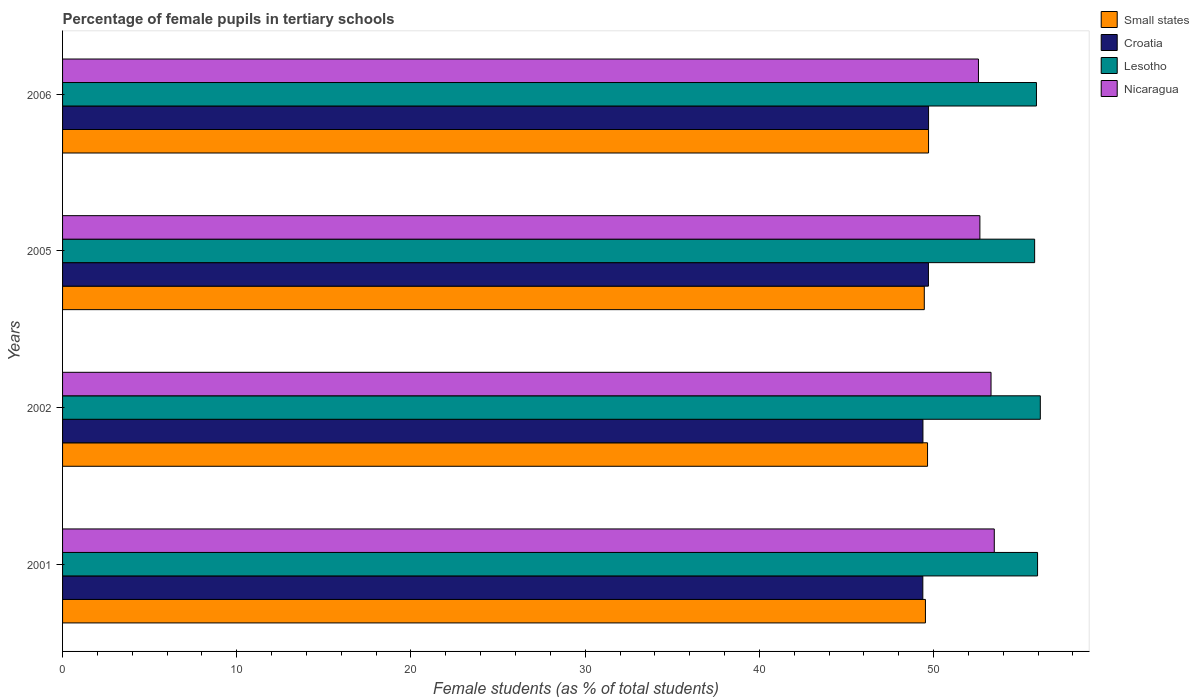Are the number of bars per tick equal to the number of legend labels?
Keep it short and to the point. Yes. Are the number of bars on each tick of the Y-axis equal?
Your answer should be compact. Yes. How many bars are there on the 2nd tick from the bottom?
Give a very brief answer. 4. In how many cases, is the number of bars for a given year not equal to the number of legend labels?
Offer a very short reply. 0. What is the percentage of female pupils in tertiary schools in Nicaragua in 2005?
Your answer should be compact. 52.66. Across all years, what is the maximum percentage of female pupils in tertiary schools in Lesotho?
Ensure brevity in your answer.  56.13. Across all years, what is the minimum percentage of female pupils in tertiary schools in Croatia?
Make the answer very short. 49.38. In which year was the percentage of female pupils in tertiary schools in Nicaragua maximum?
Provide a short and direct response. 2001. What is the total percentage of female pupils in tertiary schools in Croatia in the graph?
Your response must be concise. 198.19. What is the difference between the percentage of female pupils in tertiary schools in Nicaragua in 2001 and that in 2002?
Ensure brevity in your answer.  0.19. What is the difference between the percentage of female pupils in tertiary schools in Nicaragua in 2005 and the percentage of female pupils in tertiary schools in Small states in 2002?
Provide a short and direct response. 3. What is the average percentage of female pupils in tertiary schools in Nicaragua per year?
Provide a succinct answer. 53.01. In the year 2006, what is the difference between the percentage of female pupils in tertiary schools in Small states and percentage of female pupils in tertiary schools in Croatia?
Make the answer very short. -0. In how many years, is the percentage of female pupils in tertiary schools in Croatia greater than 22 %?
Your response must be concise. 4. What is the ratio of the percentage of female pupils in tertiary schools in Nicaragua in 2002 to that in 2005?
Your response must be concise. 1.01. What is the difference between the highest and the second highest percentage of female pupils in tertiary schools in Small states?
Make the answer very short. 0.06. What is the difference between the highest and the lowest percentage of female pupils in tertiary schools in Small states?
Ensure brevity in your answer.  0.24. In how many years, is the percentage of female pupils in tertiary schools in Croatia greater than the average percentage of female pupils in tertiary schools in Croatia taken over all years?
Your answer should be compact. 2. Is the sum of the percentage of female pupils in tertiary schools in Lesotho in 2001 and 2006 greater than the maximum percentage of female pupils in tertiary schools in Croatia across all years?
Your answer should be very brief. Yes. What does the 3rd bar from the top in 2005 represents?
Your response must be concise. Croatia. What does the 3rd bar from the bottom in 2005 represents?
Provide a succinct answer. Lesotho. Is it the case that in every year, the sum of the percentage of female pupils in tertiary schools in Croatia and percentage of female pupils in tertiary schools in Lesotho is greater than the percentage of female pupils in tertiary schools in Nicaragua?
Provide a short and direct response. Yes. How many bars are there?
Make the answer very short. 16. Are all the bars in the graph horizontal?
Offer a terse response. Yes. What is the difference between two consecutive major ticks on the X-axis?
Offer a terse response. 10. Does the graph contain any zero values?
Make the answer very short. No. Where does the legend appear in the graph?
Provide a succinct answer. Top right. What is the title of the graph?
Your answer should be compact. Percentage of female pupils in tertiary schools. Does "Sub-Saharan Africa (all income levels)" appear as one of the legend labels in the graph?
Make the answer very short. No. What is the label or title of the X-axis?
Keep it short and to the point. Female students (as % of total students). What is the Female students (as % of total students) of Small states in 2001?
Offer a terse response. 49.53. What is the Female students (as % of total students) of Croatia in 2001?
Your answer should be compact. 49.38. What is the Female students (as % of total students) of Lesotho in 2001?
Your answer should be very brief. 55.97. What is the Female students (as % of total students) in Nicaragua in 2001?
Ensure brevity in your answer.  53.49. What is the Female students (as % of total students) of Small states in 2002?
Keep it short and to the point. 49.66. What is the Female students (as % of total students) in Croatia in 2002?
Your answer should be compact. 49.39. What is the Female students (as % of total students) in Lesotho in 2002?
Your answer should be compact. 56.13. What is the Female students (as % of total students) in Nicaragua in 2002?
Offer a terse response. 53.3. What is the Female students (as % of total students) of Small states in 2005?
Provide a short and direct response. 49.47. What is the Female students (as % of total students) of Croatia in 2005?
Provide a succinct answer. 49.71. What is the Female students (as % of total students) of Lesotho in 2005?
Your answer should be very brief. 55.8. What is the Female students (as % of total students) of Nicaragua in 2005?
Your response must be concise. 52.66. What is the Female students (as % of total students) in Small states in 2006?
Your response must be concise. 49.71. What is the Female students (as % of total students) of Croatia in 2006?
Make the answer very short. 49.71. What is the Female students (as % of total students) in Lesotho in 2006?
Make the answer very short. 55.91. What is the Female students (as % of total students) of Nicaragua in 2006?
Provide a succinct answer. 52.58. Across all years, what is the maximum Female students (as % of total students) of Small states?
Make the answer very short. 49.71. Across all years, what is the maximum Female students (as % of total students) of Croatia?
Offer a terse response. 49.71. Across all years, what is the maximum Female students (as % of total students) in Lesotho?
Keep it short and to the point. 56.13. Across all years, what is the maximum Female students (as % of total students) in Nicaragua?
Your answer should be very brief. 53.49. Across all years, what is the minimum Female students (as % of total students) of Small states?
Ensure brevity in your answer.  49.47. Across all years, what is the minimum Female students (as % of total students) of Croatia?
Offer a very short reply. 49.38. Across all years, what is the minimum Female students (as % of total students) of Lesotho?
Make the answer very short. 55.8. Across all years, what is the minimum Female students (as % of total students) in Nicaragua?
Provide a short and direct response. 52.58. What is the total Female students (as % of total students) in Small states in the graph?
Your response must be concise. 198.37. What is the total Female students (as % of total students) of Croatia in the graph?
Provide a short and direct response. 198.19. What is the total Female students (as % of total students) in Lesotho in the graph?
Give a very brief answer. 223.81. What is the total Female students (as % of total students) of Nicaragua in the graph?
Keep it short and to the point. 212.02. What is the difference between the Female students (as % of total students) in Small states in 2001 and that in 2002?
Offer a terse response. -0.12. What is the difference between the Female students (as % of total students) in Croatia in 2001 and that in 2002?
Provide a succinct answer. -0.01. What is the difference between the Female students (as % of total students) in Lesotho in 2001 and that in 2002?
Your response must be concise. -0.16. What is the difference between the Female students (as % of total students) in Nicaragua in 2001 and that in 2002?
Keep it short and to the point. 0.19. What is the difference between the Female students (as % of total students) in Small states in 2001 and that in 2005?
Make the answer very short. 0.07. What is the difference between the Female students (as % of total students) of Croatia in 2001 and that in 2005?
Ensure brevity in your answer.  -0.32. What is the difference between the Female students (as % of total students) in Lesotho in 2001 and that in 2005?
Your answer should be very brief. 0.17. What is the difference between the Female students (as % of total students) of Nicaragua in 2001 and that in 2005?
Your response must be concise. 0.83. What is the difference between the Female students (as % of total students) in Small states in 2001 and that in 2006?
Provide a succinct answer. -0.18. What is the difference between the Female students (as % of total students) of Croatia in 2001 and that in 2006?
Your response must be concise. -0.33. What is the difference between the Female students (as % of total students) of Lesotho in 2001 and that in 2006?
Keep it short and to the point. 0.06. What is the difference between the Female students (as % of total students) in Small states in 2002 and that in 2005?
Give a very brief answer. 0.19. What is the difference between the Female students (as % of total students) of Croatia in 2002 and that in 2005?
Your answer should be very brief. -0.32. What is the difference between the Female students (as % of total students) of Lesotho in 2002 and that in 2005?
Make the answer very short. 0.33. What is the difference between the Female students (as % of total students) of Nicaragua in 2002 and that in 2005?
Provide a succinct answer. 0.64. What is the difference between the Female students (as % of total students) in Small states in 2002 and that in 2006?
Provide a short and direct response. -0.06. What is the difference between the Female students (as % of total students) in Croatia in 2002 and that in 2006?
Your answer should be very brief. -0.32. What is the difference between the Female students (as % of total students) in Lesotho in 2002 and that in 2006?
Your answer should be very brief. 0.22. What is the difference between the Female students (as % of total students) of Nicaragua in 2002 and that in 2006?
Your response must be concise. 0.72. What is the difference between the Female students (as % of total students) of Small states in 2005 and that in 2006?
Offer a very short reply. -0.24. What is the difference between the Female students (as % of total students) in Croatia in 2005 and that in 2006?
Keep it short and to the point. -0.01. What is the difference between the Female students (as % of total students) of Lesotho in 2005 and that in 2006?
Offer a terse response. -0.1. What is the difference between the Female students (as % of total students) of Nicaragua in 2005 and that in 2006?
Provide a short and direct response. 0.08. What is the difference between the Female students (as % of total students) of Small states in 2001 and the Female students (as % of total students) of Croatia in 2002?
Give a very brief answer. 0.14. What is the difference between the Female students (as % of total students) in Small states in 2001 and the Female students (as % of total students) in Lesotho in 2002?
Provide a succinct answer. -6.59. What is the difference between the Female students (as % of total students) in Small states in 2001 and the Female students (as % of total students) in Nicaragua in 2002?
Provide a short and direct response. -3.77. What is the difference between the Female students (as % of total students) in Croatia in 2001 and the Female students (as % of total students) in Lesotho in 2002?
Make the answer very short. -6.74. What is the difference between the Female students (as % of total students) of Croatia in 2001 and the Female students (as % of total students) of Nicaragua in 2002?
Make the answer very short. -3.92. What is the difference between the Female students (as % of total students) in Lesotho in 2001 and the Female students (as % of total students) in Nicaragua in 2002?
Your answer should be very brief. 2.67. What is the difference between the Female students (as % of total students) in Small states in 2001 and the Female students (as % of total students) in Croatia in 2005?
Make the answer very short. -0.17. What is the difference between the Female students (as % of total students) in Small states in 2001 and the Female students (as % of total students) in Lesotho in 2005?
Your answer should be very brief. -6.27. What is the difference between the Female students (as % of total students) in Small states in 2001 and the Female students (as % of total students) in Nicaragua in 2005?
Keep it short and to the point. -3.13. What is the difference between the Female students (as % of total students) of Croatia in 2001 and the Female students (as % of total students) of Lesotho in 2005?
Your answer should be compact. -6.42. What is the difference between the Female students (as % of total students) in Croatia in 2001 and the Female students (as % of total students) in Nicaragua in 2005?
Keep it short and to the point. -3.28. What is the difference between the Female students (as % of total students) of Lesotho in 2001 and the Female students (as % of total students) of Nicaragua in 2005?
Provide a succinct answer. 3.31. What is the difference between the Female students (as % of total students) in Small states in 2001 and the Female students (as % of total students) in Croatia in 2006?
Keep it short and to the point. -0.18. What is the difference between the Female students (as % of total students) in Small states in 2001 and the Female students (as % of total students) in Lesotho in 2006?
Your answer should be very brief. -6.37. What is the difference between the Female students (as % of total students) of Small states in 2001 and the Female students (as % of total students) of Nicaragua in 2006?
Ensure brevity in your answer.  -3.04. What is the difference between the Female students (as % of total students) in Croatia in 2001 and the Female students (as % of total students) in Lesotho in 2006?
Your answer should be compact. -6.52. What is the difference between the Female students (as % of total students) in Croatia in 2001 and the Female students (as % of total students) in Nicaragua in 2006?
Provide a short and direct response. -3.19. What is the difference between the Female students (as % of total students) of Lesotho in 2001 and the Female students (as % of total students) of Nicaragua in 2006?
Your response must be concise. 3.39. What is the difference between the Female students (as % of total students) of Small states in 2002 and the Female students (as % of total students) of Croatia in 2005?
Make the answer very short. -0.05. What is the difference between the Female students (as % of total students) in Small states in 2002 and the Female students (as % of total students) in Lesotho in 2005?
Give a very brief answer. -6.15. What is the difference between the Female students (as % of total students) in Small states in 2002 and the Female students (as % of total students) in Nicaragua in 2005?
Make the answer very short. -3. What is the difference between the Female students (as % of total students) in Croatia in 2002 and the Female students (as % of total students) in Lesotho in 2005?
Offer a very short reply. -6.41. What is the difference between the Female students (as % of total students) of Croatia in 2002 and the Female students (as % of total students) of Nicaragua in 2005?
Your answer should be very brief. -3.27. What is the difference between the Female students (as % of total students) of Lesotho in 2002 and the Female students (as % of total students) of Nicaragua in 2005?
Your response must be concise. 3.47. What is the difference between the Female students (as % of total students) of Small states in 2002 and the Female students (as % of total students) of Croatia in 2006?
Your answer should be very brief. -0.06. What is the difference between the Female students (as % of total students) in Small states in 2002 and the Female students (as % of total students) in Lesotho in 2006?
Offer a very short reply. -6.25. What is the difference between the Female students (as % of total students) in Small states in 2002 and the Female students (as % of total students) in Nicaragua in 2006?
Give a very brief answer. -2.92. What is the difference between the Female students (as % of total students) in Croatia in 2002 and the Female students (as % of total students) in Lesotho in 2006?
Keep it short and to the point. -6.52. What is the difference between the Female students (as % of total students) in Croatia in 2002 and the Female students (as % of total students) in Nicaragua in 2006?
Your answer should be very brief. -3.19. What is the difference between the Female students (as % of total students) in Lesotho in 2002 and the Female students (as % of total students) in Nicaragua in 2006?
Offer a very short reply. 3.55. What is the difference between the Female students (as % of total students) of Small states in 2005 and the Female students (as % of total students) of Croatia in 2006?
Keep it short and to the point. -0.24. What is the difference between the Female students (as % of total students) of Small states in 2005 and the Female students (as % of total students) of Lesotho in 2006?
Your response must be concise. -6.44. What is the difference between the Female students (as % of total students) in Small states in 2005 and the Female students (as % of total students) in Nicaragua in 2006?
Your answer should be very brief. -3.11. What is the difference between the Female students (as % of total students) of Croatia in 2005 and the Female students (as % of total students) of Lesotho in 2006?
Your answer should be compact. -6.2. What is the difference between the Female students (as % of total students) of Croatia in 2005 and the Female students (as % of total students) of Nicaragua in 2006?
Ensure brevity in your answer.  -2.87. What is the difference between the Female students (as % of total students) of Lesotho in 2005 and the Female students (as % of total students) of Nicaragua in 2006?
Offer a very short reply. 3.23. What is the average Female students (as % of total students) of Small states per year?
Make the answer very short. 49.59. What is the average Female students (as % of total students) in Croatia per year?
Make the answer very short. 49.55. What is the average Female students (as % of total students) of Lesotho per year?
Provide a short and direct response. 55.95. What is the average Female students (as % of total students) of Nicaragua per year?
Provide a succinct answer. 53.01. In the year 2001, what is the difference between the Female students (as % of total students) in Small states and Female students (as % of total students) in Croatia?
Give a very brief answer. 0.15. In the year 2001, what is the difference between the Female students (as % of total students) in Small states and Female students (as % of total students) in Lesotho?
Offer a very short reply. -6.44. In the year 2001, what is the difference between the Female students (as % of total students) in Small states and Female students (as % of total students) in Nicaragua?
Ensure brevity in your answer.  -3.95. In the year 2001, what is the difference between the Female students (as % of total students) in Croatia and Female students (as % of total students) in Lesotho?
Offer a terse response. -6.59. In the year 2001, what is the difference between the Female students (as % of total students) in Croatia and Female students (as % of total students) in Nicaragua?
Make the answer very short. -4.1. In the year 2001, what is the difference between the Female students (as % of total students) in Lesotho and Female students (as % of total students) in Nicaragua?
Keep it short and to the point. 2.48. In the year 2002, what is the difference between the Female students (as % of total students) of Small states and Female students (as % of total students) of Croatia?
Offer a terse response. 0.27. In the year 2002, what is the difference between the Female students (as % of total students) in Small states and Female students (as % of total students) in Lesotho?
Offer a terse response. -6.47. In the year 2002, what is the difference between the Female students (as % of total students) of Small states and Female students (as % of total students) of Nicaragua?
Provide a succinct answer. -3.64. In the year 2002, what is the difference between the Female students (as % of total students) of Croatia and Female students (as % of total students) of Lesotho?
Keep it short and to the point. -6.74. In the year 2002, what is the difference between the Female students (as % of total students) in Croatia and Female students (as % of total students) in Nicaragua?
Your answer should be compact. -3.91. In the year 2002, what is the difference between the Female students (as % of total students) of Lesotho and Female students (as % of total students) of Nicaragua?
Give a very brief answer. 2.83. In the year 2005, what is the difference between the Female students (as % of total students) in Small states and Female students (as % of total students) in Croatia?
Make the answer very short. -0.24. In the year 2005, what is the difference between the Female students (as % of total students) in Small states and Female students (as % of total students) in Lesotho?
Offer a very short reply. -6.33. In the year 2005, what is the difference between the Female students (as % of total students) of Small states and Female students (as % of total students) of Nicaragua?
Your response must be concise. -3.19. In the year 2005, what is the difference between the Female students (as % of total students) of Croatia and Female students (as % of total students) of Lesotho?
Provide a succinct answer. -6.1. In the year 2005, what is the difference between the Female students (as % of total students) of Croatia and Female students (as % of total students) of Nicaragua?
Provide a succinct answer. -2.95. In the year 2005, what is the difference between the Female students (as % of total students) of Lesotho and Female students (as % of total students) of Nicaragua?
Offer a terse response. 3.14. In the year 2006, what is the difference between the Female students (as % of total students) of Small states and Female students (as % of total students) of Croatia?
Your answer should be compact. -0. In the year 2006, what is the difference between the Female students (as % of total students) in Small states and Female students (as % of total students) in Lesotho?
Your answer should be very brief. -6.19. In the year 2006, what is the difference between the Female students (as % of total students) in Small states and Female students (as % of total students) in Nicaragua?
Your response must be concise. -2.86. In the year 2006, what is the difference between the Female students (as % of total students) of Croatia and Female students (as % of total students) of Lesotho?
Provide a succinct answer. -6.19. In the year 2006, what is the difference between the Female students (as % of total students) of Croatia and Female students (as % of total students) of Nicaragua?
Offer a very short reply. -2.86. In the year 2006, what is the difference between the Female students (as % of total students) in Lesotho and Female students (as % of total students) in Nicaragua?
Offer a terse response. 3.33. What is the ratio of the Female students (as % of total students) of Small states in 2001 to that in 2002?
Provide a short and direct response. 1. What is the ratio of the Female students (as % of total students) in Croatia in 2001 to that in 2002?
Ensure brevity in your answer.  1. What is the ratio of the Female students (as % of total students) of Lesotho in 2001 to that in 2002?
Keep it short and to the point. 1. What is the ratio of the Female students (as % of total students) of Small states in 2001 to that in 2005?
Make the answer very short. 1. What is the ratio of the Female students (as % of total students) in Lesotho in 2001 to that in 2005?
Offer a very short reply. 1. What is the ratio of the Female students (as % of total students) of Nicaragua in 2001 to that in 2005?
Provide a short and direct response. 1.02. What is the ratio of the Female students (as % of total students) of Small states in 2001 to that in 2006?
Provide a short and direct response. 1. What is the ratio of the Female students (as % of total students) of Croatia in 2001 to that in 2006?
Make the answer very short. 0.99. What is the ratio of the Female students (as % of total students) of Lesotho in 2001 to that in 2006?
Ensure brevity in your answer.  1. What is the ratio of the Female students (as % of total students) in Nicaragua in 2001 to that in 2006?
Give a very brief answer. 1.02. What is the ratio of the Female students (as % of total students) in Small states in 2002 to that in 2005?
Ensure brevity in your answer.  1. What is the ratio of the Female students (as % of total students) in Nicaragua in 2002 to that in 2005?
Your response must be concise. 1.01. What is the ratio of the Female students (as % of total students) in Small states in 2002 to that in 2006?
Keep it short and to the point. 1. What is the ratio of the Female students (as % of total students) in Croatia in 2002 to that in 2006?
Offer a terse response. 0.99. What is the ratio of the Female students (as % of total students) of Lesotho in 2002 to that in 2006?
Offer a terse response. 1. What is the ratio of the Female students (as % of total students) of Nicaragua in 2002 to that in 2006?
Offer a terse response. 1.01. What is the ratio of the Female students (as % of total students) in Small states in 2005 to that in 2006?
Ensure brevity in your answer.  1. What is the ratio of the Female students (as % of total students) of Nicaragua in 2005 to that in 2006?
Keep it short and to the point. 1. What is the difference between the highest and the second highest Female students (as % of total students) of Small states?
Give a very brief answer. 0.06. What is the difference between the highest and the second highest Female students (as % of total students) of Croatia?
Provide a short and direct response. 0.01. What is the difference between the highest and the second highest Female students (as % of total students) of Lesotho?
Keep it short and to the point. 0.16. What is the difference between the highest and the second highest Female students (as % of total students) of Nicaragua?
Keep it short and to the point. 0.19. What is the difference between the highest and the lowest Female students (as % of total students) in Small states?
Provide a short and direct response. 0.24. What is the difference between the highest and the lowest Female students (as % of total students) of Croatia?
Your answer should be compact. 0.33. What is the difference between the highest and the lowest Female students (as % of total students) of Lesotho?
Your answer should be very brief. 0.33. What is the difference between the highest and the lowest Female students (as % of total students) in Nicaragua?
Your answer should be very brief. 0.91. 